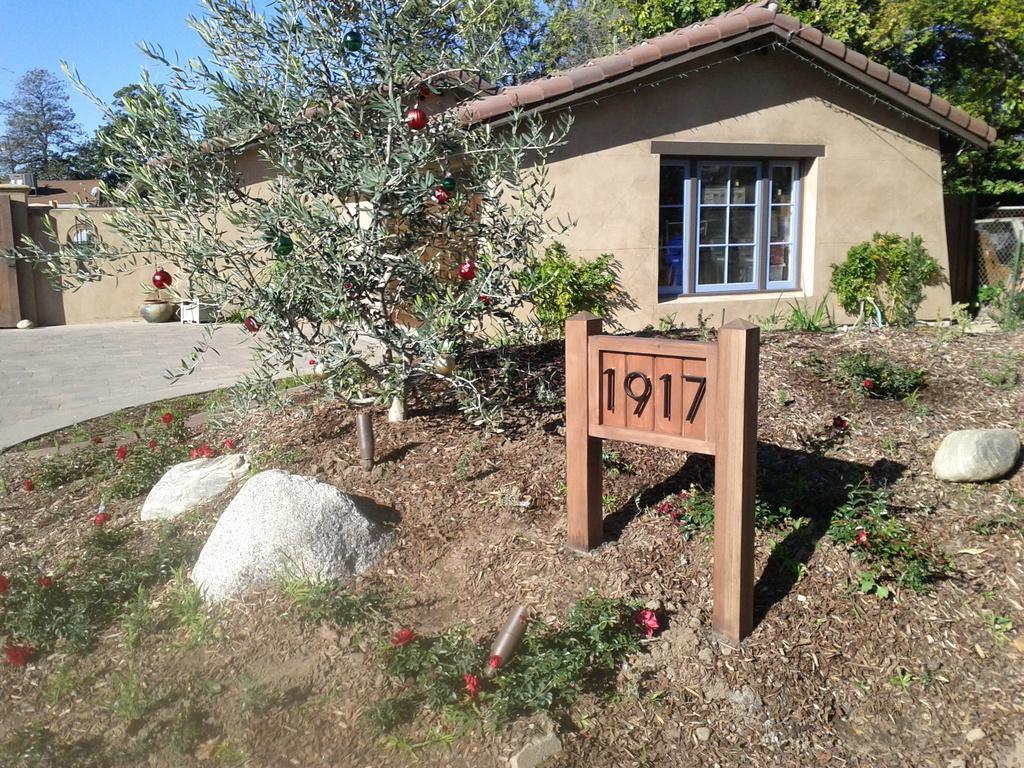How would you summarize this image in a sentence or two? In this image in the front there is a board with some text written on it and there are flowers and stones on the ground. In the center there are plants and there is a house in the background and there are trees and on the right side there is a fence. 